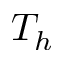Convert formula to latex. <formula><loc_0><loc_0><loc_500><loc_500>T _ { h }</formula> 